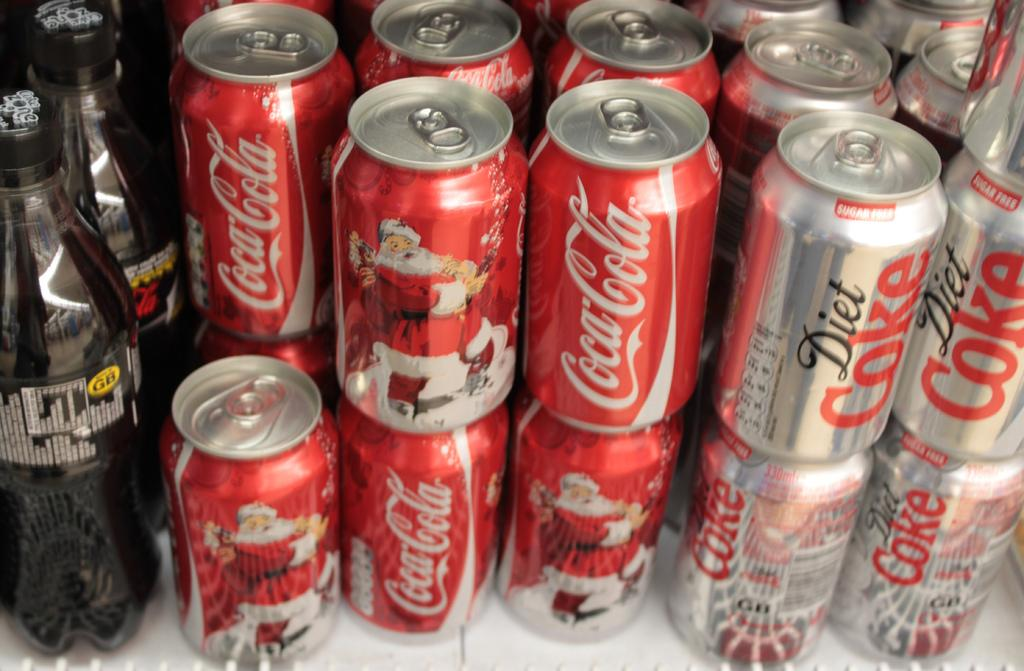Where was the image taken? The image was taken in a store. What can be seen in the store? There is a shelf in the image. What items are on the shelf? There are cans of coke on the shelf and two bottles with a label. What type of joke is written on the cans of coke in the image? There is no joke written on the cans of coke in the image; they are simply labeled as Coke. 